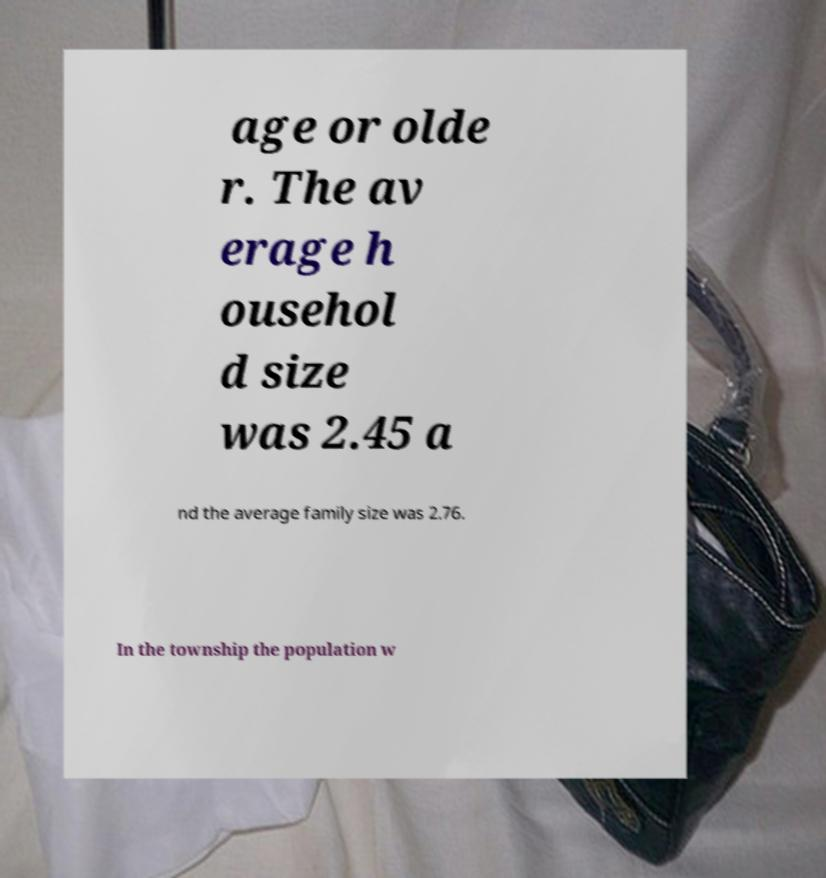Please identify and transcribe the text found in this image. age or olde r. The av erage h ousehol d size was 2.45 a nd the average family size was 2.76. In the township the population w 